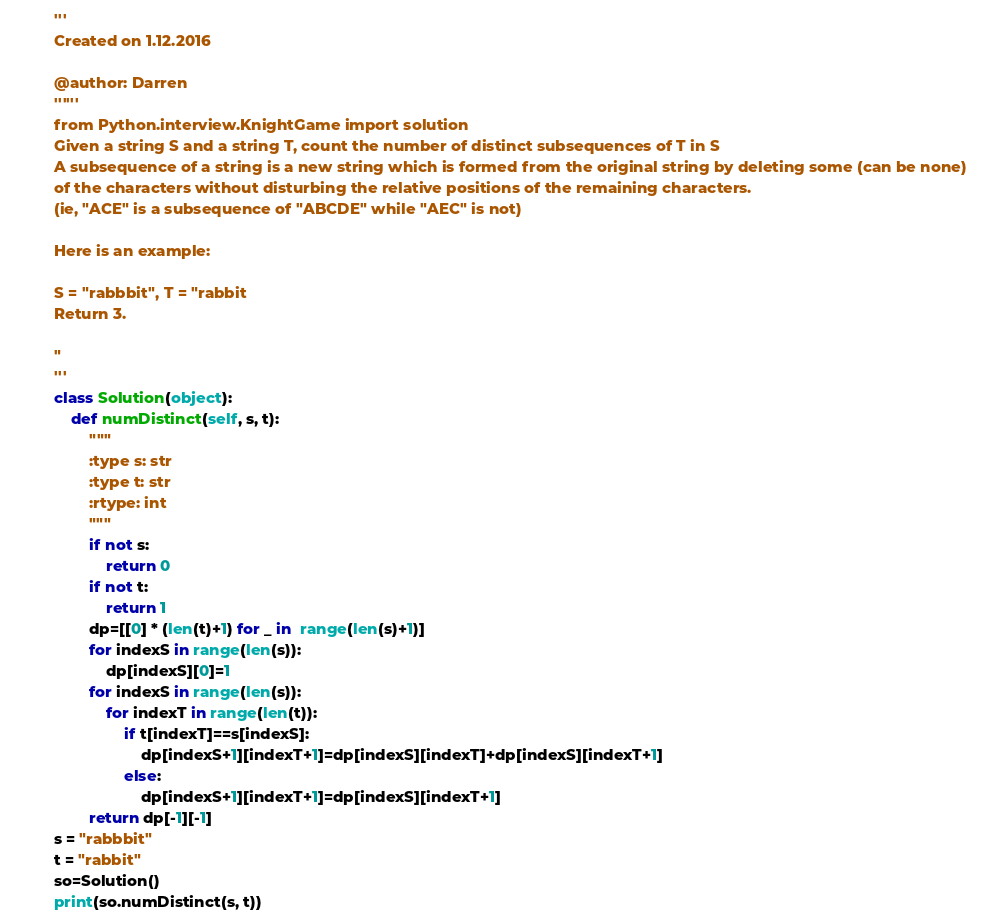Convert code to text. <code><loc_0><loc_0><loc_500><loc_500><_Python_>'''
Created on 1.12.2016

@author: Darren
''''''
from Python.interview.KnightGame import solution
Given a string S and a string T, count the number of distinct subsequences of T in S
A subsequence of a string is a new string which is formed from the original string by deleting some (can be none) 
of the characters without disturbing the relative positions of the remaining characters. 
(ie, "ACE" is a subsequence of "ABCDE" while "AEC" is not)
Here is an example:
S = "rabbbit", T = "rabbit
Return 3.
" 
'''
class Solution(object):
    def numDistinct(self, s, t):
        """
        :type s: str
        :type t: str
        :rtype: int
        """
        if not s:
            return 0
        if not t:
            return 1
        dp=[[0] * (len(t)+1) for _ in  range(len(s)+1)]
        for indexS in range(len(s)): 
            dp[indexS][0]=1
        for indexS in range(len(s)):
            for indexT in range(len(t)):
                if t[indexT]==s[indexS]:
                    dp[indexS+1][indexT+1]=dp[indexS][indexT]+dp[indexS][indexT+1]
                else:
                    dp[indexS+1][indexT+1]=dp[indexS][indexT+1]
        return dp[-1][-1]
s = "rabbbit"
t = "rabbit"
so=Solution()
print(so.numDistinct(s, t))</code> 